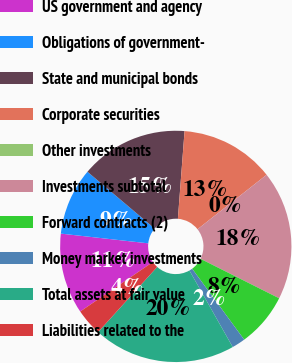Convert chart to OTSL. <chart><loc_0><loc_0><loc_500><loc_500><pie_chart><fcel>US government and agency<fcel>Obligations of government-<fcel>State and municipal bonds<fcel>Corporate securities<fcel>Other investments<fcel>Investments subtotal<fcel>Forward contracts (2)<fcel>Money market investments<fcel>Total assets at fair value<fcel>Liabilities related to the<nl><fcel>11.28%<fcel>9.4%<fcel>15.04%<fcel>13.16%<fcel>0.0%<fcel>18.03%<fcel>7.52%<fcel>1.88%<fcel>19.91%<fcel>3.76%<nl></chart> 